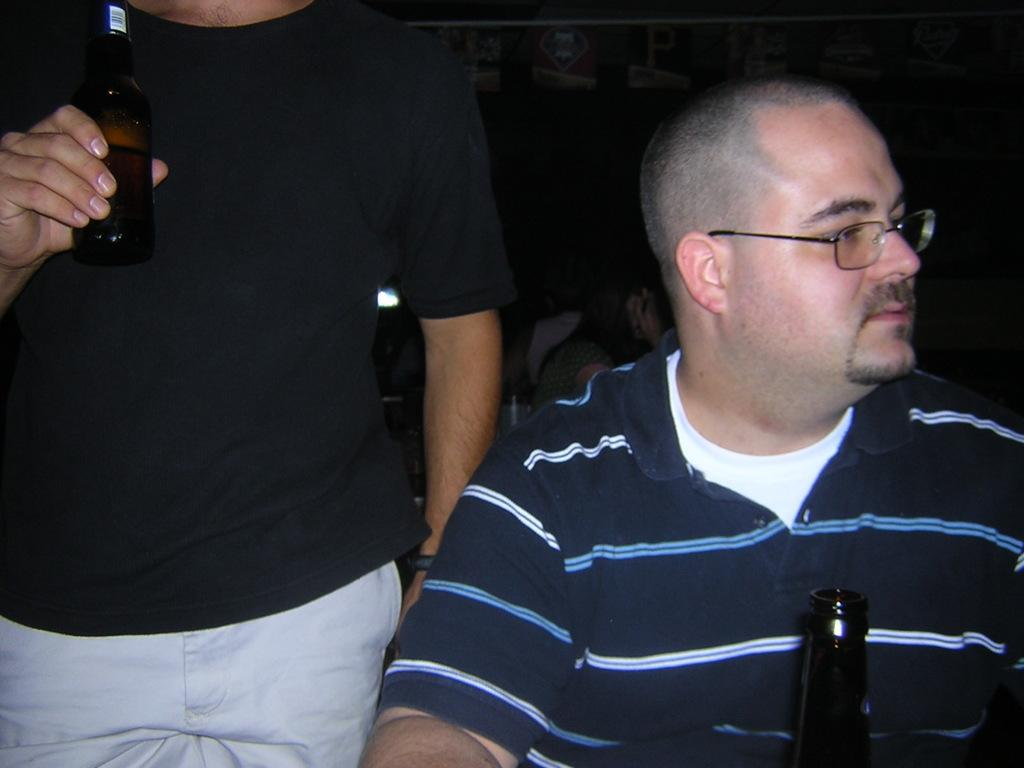Who is present in the image? There is a man in the image. What can be seen on the man's face? The man is wearing spectacles. What object is visible in the image? There is a bottle in the image. How is the man interacting with the bottle? The man is holding the bottle with his hand. How many boys are playing with lizards in the image? There are no boys or lizards present in the image; it features a man holding a bottle. 